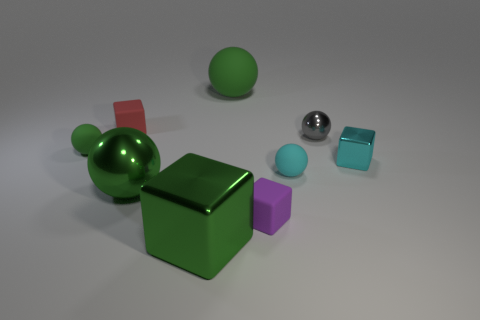Can you describe the lighting and shadows present in the scene? The image shows diffused lighting, casting soft shadows beneath each object. The light appears to be coming from the upper left, as indicated by the shadow directions. The shadows are elongated and soft-edged, suggesting an indirect or ambient light source rather than a direct spot light. 